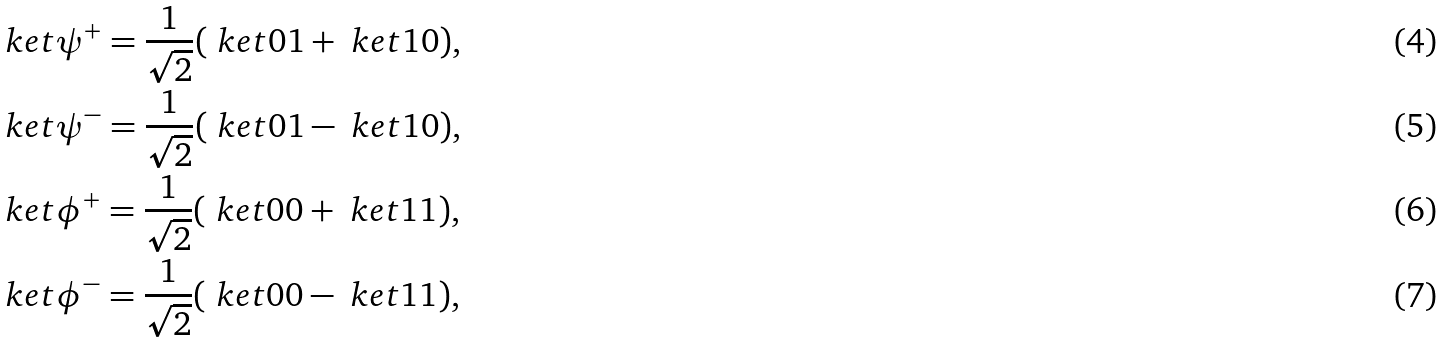Convert formula to latex. <formula><loc_0><loc_0><loc_500><loc_500>& \ k e t { \psi ^ { + } } = \frac { 1 } { \sqrt { 2 } } ( \ k e t { 0 1 } + \ k e t { 1 0 } ) , \\ & \ k e t { \psi ^ { - } } = \frac { 1 } { \sqrt { 2 } } ( \ k e t { 0 1 } - \ k e t { 1 0 } ) , \\ & \ k e t { \phi ^ { + } } = \frac { 1 } { \sqrt { 2 } } ( \ k e t { 0 0 } + \ k e t { 1 1 } ) , \\ & \ k e t { \phi ^ { - } } = \frac { 1 } { \sqrt { 2 } } ( \ k e t { 0 0 } - \ k e t { 1 1 } ) ,</formula> 